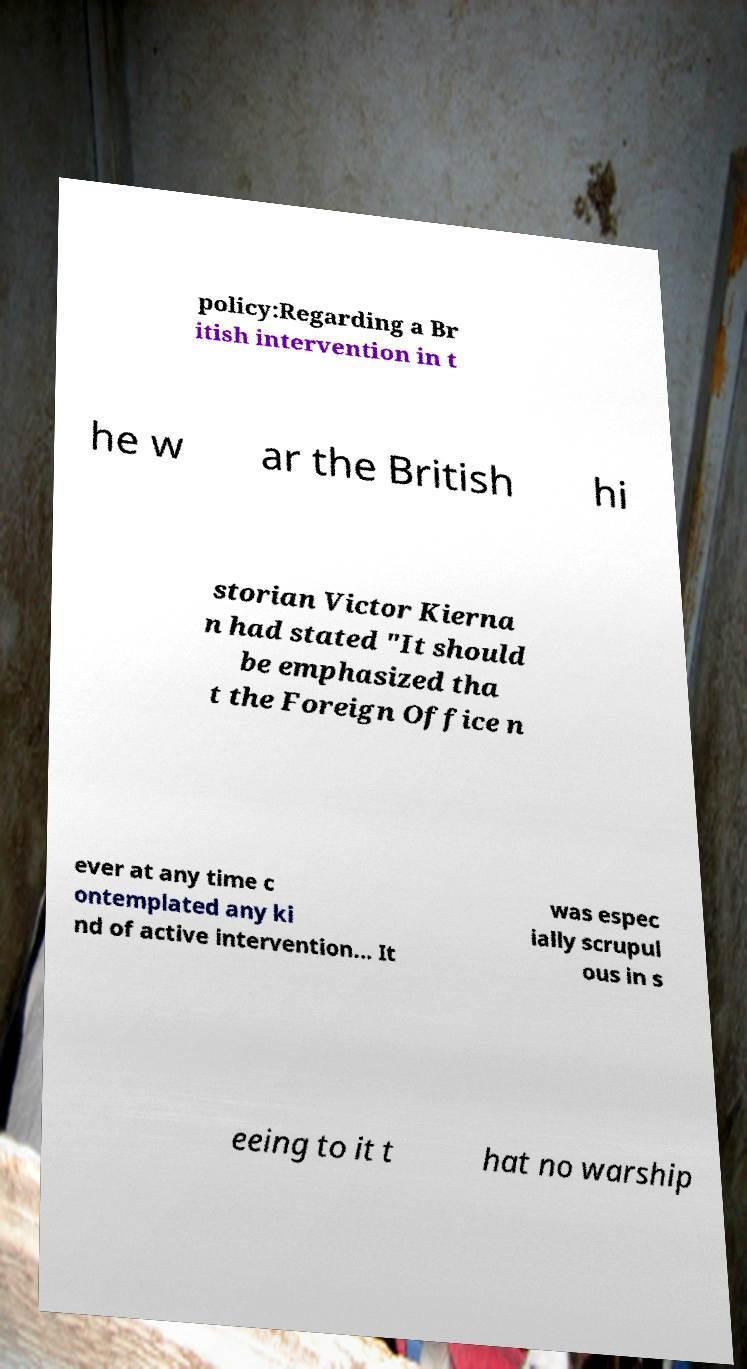Can you read and provide the text displayed in the image?This photo seems to have some interesting text. Can you extract and type it out for me? policy:Regarding a Br itish intervention in t he w ar the British hi storian Victor Kierna n had stated "It should be emphasized tha t the Foreign Office n ever at any time c ontemplated any ki nd of active intervention... It was espec ially scrupul ous in s eeing to it t hat no warship 